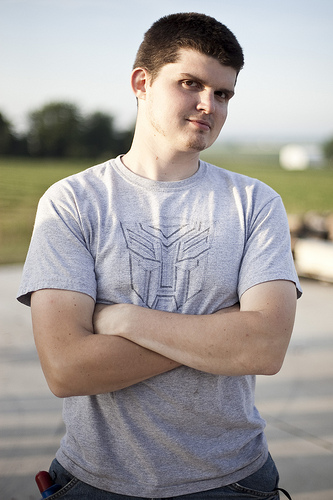<image>
Is the boy in the tshirt? Yes. The boy is contained within or inside the tshirt, showing a containment relationship. 